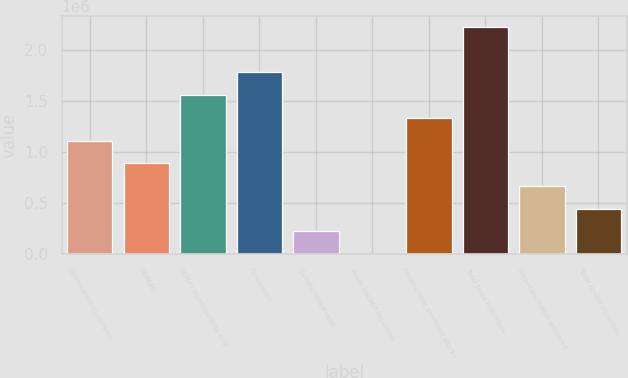<chart> <loc_0><loc_0><loc_500><loc_500><bar_chart><fcel>Government-sponsored<fcel>GNMAs<fcel>States municipalities and<fcel>Corporates<fcel>Collateralized debt<fcel>Asset-backed securities<fcel>Redeemable preferred stocks<fcel>Total fixed maturities<fcel>Non-redeemable preferred<fcel>Total equity securities<nl><fcel>1.11349e+06<fcel>890795<fcel>1.55889e+06<fcel>1.78159e+06<fcel>222699<fcel>0.68<fcel>1.33619e+06<fcel>2.22699e+06<fcel>668097<fcel>445398<nl></chart> 